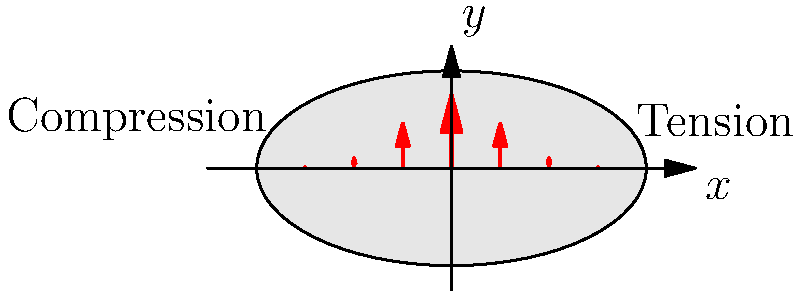A cross-sectional view of a bone under bending load is shown above. The stress distribution is represented by the red arrows, where longer arrows indicate higher stress. Based on this diagram, what type of loading is the bone experiencing, and where are the maximum tensile and compressive stresses located? To analyze the stress distribution in the bone:

1. Observe the arrow directions:
   - Arrows pointing upward (positive y-direction) indicate tensile stress.
   - Arrows pointing downward (negative y-direction) indicate compressive stress.

2. Notice the arrow lengths:
   - Longer arrows represent higher stress magnitudes.
   - Shorter arrows represent lower stress magnitudes.

3. Identify the loading type:
   - The stress distribution shows tension on the right side and compression on the left side.
   - This pattern is characteristic of bending load.

4. Locate maximum stresses:
   - The longest arrows are at the outermost fibers of the bone cross-section.
   - Maximum tensile stress is at the rightmost point (x-positive).
   - Maximum compressive stress is at the leftmost point (x-negative).

5. Neutral axis:
   - The point where arrows change direction (at x = 0) is the neutral axis.
   - Stress is zero at the neutral axis.

Therefore, the bone is experiencing bending load, with maximum tensile stress at the rightmost point and maximum compressive stress at the leftmost point of the cross-section.
Answer: Bending load; maximum tension at rightmost point, maximum compression at leftmost point. 